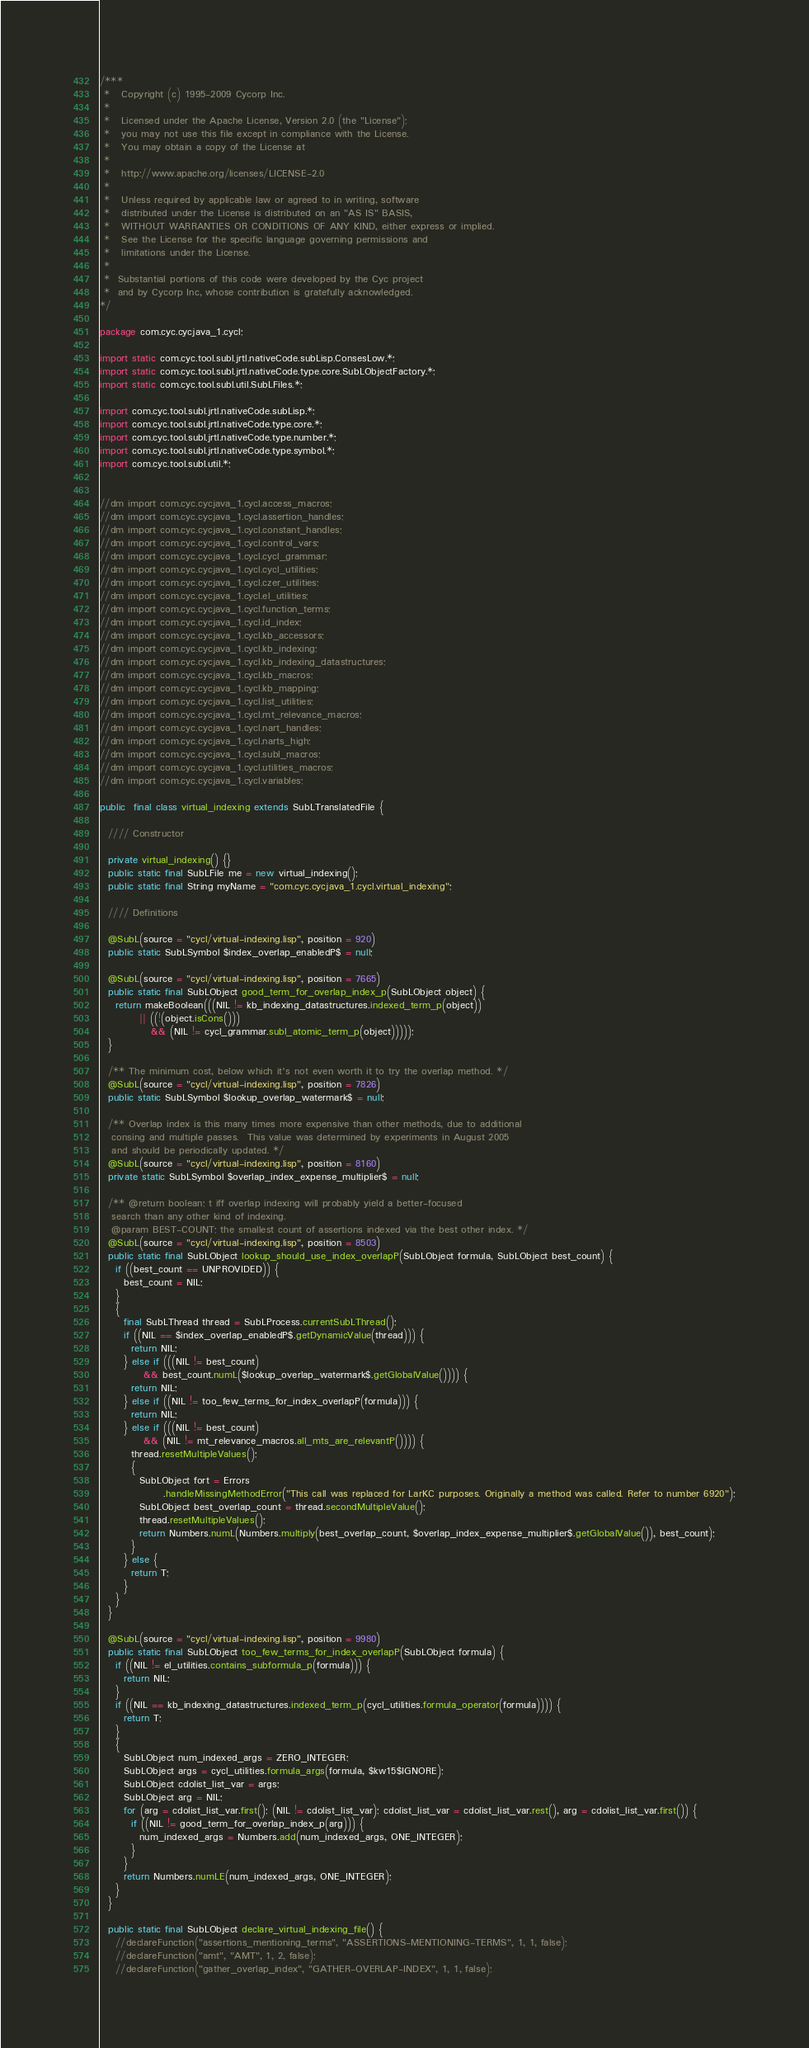Convert code to text. <code><loc_0><loc_0><loc_500><loc_500><_Java_>/***
 *   Copyright (c) 1995-2009 Cycorp Inc.
 * 
 *   Licensed under the Apache License, Version 2.0 (the "License");
 *   you may not use this file except in compliance with the License.
 *   You may obtain a copy of the License at
 *   
 *   http://www.apache.org/licenses/LICENSE-2.0
 * 
 *   Unless required by applicable law or agreed to in writing, software
 *   distributed under the License is distributed on an "AS IS" BASIS,
 *   WITHOUT WARRANTIES OR CONDITIONS OF ANY KIND, either express or implied.
 *   See the License for the specific language governing permissions and
 *   limitations under the License.
 *
 *  Substantial portions of this code were developed by the Cyc project
 *  and by Cycorp Inc, whose contribution is gratefully acknowledged.
*/

package com.cyc.cycjava_1.cycl;

import static com.cyc.tool.subl.jrtl.nativeCode.subLisp.ConsesLow.*;
import static com.cyc.tool.subl.jrtl.nativeCode.type.core.SubLObjectFactory.*;
import static com.cyc.tool.subl.util.SubLFiles.*;

import com.cyc.tool.subl.jrtl.nativeCode.subLisp.*;
import com.cyc.tool.subl.jrtl.nativeCode.type.core.*;
import com.cyc.tool.subl.jrtl.nativeCode.type.number.*;
import com.cyc.tool.subl.jrtl.nativeCode.type.symbol.*;
import com.cyc.tool.subl.util.*;


//dm import com.cyc.cycjava_1.cycl.access_macros;
//dm import com.cyc.cycjava_1.cycl.assertion_handles;
//dm import com.cyc.cycjava_1.cycl.constant_handles;
//dm import com.cyc.cycjava_1.cycl.control_vars;
//dm import com.cyc.cycjava_1.cycl.cycl_grammar;
//dm import com.cyc.cycjava_1.cycl.cycl_utilities;
//dm import com.cyc.cycjava_1.cycl.czer_utilities;
//dm import com.cyc.cycjava_1.cycl.el_utilities;
//dm import com.cyc.cycjava_1.cycl.function_terms;
//dm import com.cyc.cycjava_1.cycl.id_index;
//dm import com.cyc.cycjava_1.cycl.kb_accessors;
//dm import com.cyc.cycjava_1.cycl.kb_indexing;
//dm import com.cyc.cycjava_1.cycl.kb_indexing_datastructures;
//dm import com.cyc.cycjava_1.cycl.kb_macros;
//dm import com.cyc.cycjava_1.cycl.kb_mapping;
//dm import com.cyc.cycjava_1.cycl.list_utilities;
//dm import com.cyc.cycjava_1.cycl.mt_relevance_macros;
//dm import com.cyc.cycjava_1.cycl.nart_handles;
//dm import com.cyc.cycjava_1.cycl.narts_high;
//dm import com.cyc.cycjava_1.cycl.subl_macros;
//dm import com.cyc.cycjava_1.cycl.utilities_macros;
//dm import com.cyc.cycjava_1.cycl.variables;

public  final class virtual_indexing extends SubLTranslatedFile {

  //// Constructor

  private virtual_indexing() {}
  public static final SubLFile me = new virtual_indexing();
  public static final String myName = "com.cyc.cycjava_1.cycl.virtual_indexing";

  //// Definitions

  @SubL(source = "cycl/virtual-indexing.lisp", position = 920) 
  public static SubLSymbol $index_overlap_enabledP$ = null;

  @SubL(source = "cycl/virtual-indexing.lisp", position = 7665) 
  public static final SubLObject good_term_for_overlap_index_p(SubLObject object) {
    return makeBoolean(((NIL != kb_indexing_datastructures.indexed_term_p(object))
          || ((!(object.isCons()))
             && (NIL != cycl_grammar.subl_atomic_term_p(object)))));
  }

  /** The minimum cost, below which it's not even worth it to try the overlap method. */
  @SubL(source = "cycl/virtual-indexing.lisp", position = 7826) 
  public static SubLSymbol $lookup_overlap_watermark$ = null;

  /** Overlap index is this many times more expensive than other methods, due to additional
   consing and multiple passes.  This value was determined by experiments in August 2005
   and should be periodically updated. */
  @SubL(source = "cycl/virtual-indexing.lisp", position = 8160) 
  private static SubLSymbol $overlap_index_expense_multiplier$ = null;

  /** @return boolean; t iff overlap indexing will probably yield a better-focused
   search than any other kind of indexing.
   @param BEST-COUNT; the smallest count of assertions indexed via the best other index. */
  @SubL(source = "cycl/virtual-indexing.lisp", position = 8503) 
  public static final SubLObject lookup_should_use_index_overlapP(SubLObject formula, SubLObject best_count) {
    if ((best_count == UNPROVIDED)) {
      best_count = NIL;
    }
    {
      final SubLThread thread = SubLProcess.currentSubLThread();
      if ((NIL == $index_overlap_enabledP$.getDynamicValue(thread))) {
        return NIL;
      } else if (((NIL != best_count)
           && best_count.numL($lookup_overlap_watermark$.getGlobalValue()))) {
        return NIL;
      } else if ((NIL != too_few_terms_for_index_overlapP(formula))) {
        return NIL;
      } else if (((NIL != best_count)
           && (NIL != mt_relevance_macros.all_mts_are_relevantP()))) {
        thread.resetMultipleValues();
        {
          SubLObject fort = Errors
				.handleMissingMethodError("This call was replaced for LarKC purposes. Originally a method was called. Refer to number 6920");
          SubLObject best_overlap_count = thread.secondMultipleValue();
          thread.resetMultipleValues();
          return Numbers.numL(Numbers.multiply(best_overlap_count, $overlap_index_expense_multiplier$.getGlobalValue()), best_count);
        }
      } else {
        return T;
      }
    }
  }

  @SubL(source = "cycl/virtual-indexing.lisp", position = 9980) 
  public static final SubLObject too_few_terms_for_index_overlapP(SubLObject formula) {
    if ((NIL != el_utilities.contains_subformula_p(formula))) {
      return NIL;
    }
    if ((NIL == kb_indexing_datastructures.indexed_term_p(cycl_utilities.formula_operator(formula)))) {
      return T;
    }
    {
      SubLObject num_indexed_args = ZERO_INTEGER;
      SubLObject args = cycl_utilities.formula_args(formula, $kw15$IGNORE);
      SubLObject cdolist_list_var = args;
      SubLObject arg = NIL;
      for (arg = cdolist_list_var.first(); (NIL != cdolist_list_var); cdolist_list_var = cdolist_list_var.rest(), arg = cdolist_list_var.first()) {
        if ((NIL != good_term_for_overlap_index_p(arg))) {
          num_indexed_args = Numbers.add(num_indexed_args, ONE_INTEGER);
        }
      }
      return Numbers.numLE(num_indexed_args, ONE_INTEGER);
    }
  }

  public static final SubLObject declare_virtual_indexing_file() {
    //declareFunction("assertions_mentioning_terms", "ASSERTIONS-MENTIONING-TERMS", 1, 1, false);
    //declareFunction("amt", "AMT", 1, 2, false);
    //declareFunction("gather_overlap_index", "GATHER-OVERLAP-INDEX", 1, 1, false);</code> 